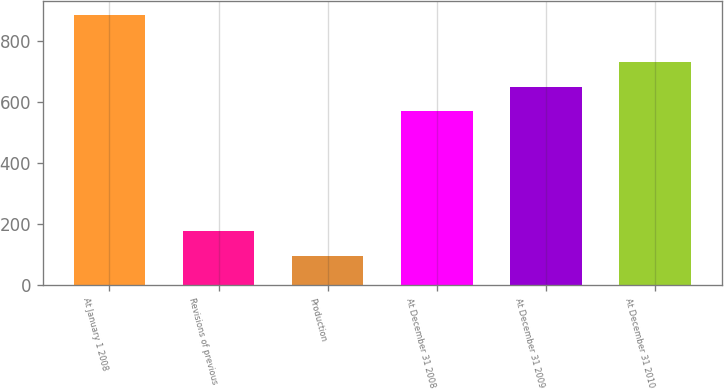<chart> <loc_0><loc_0><loc_500><loc_500><bar_chart><fcel>At January 1 2008<fcel>Revisions of previous<fcel>Production<fcel>At December 31 2008<fcel>At December 31 2009<fcel>At December 31 2010<nl><fcel>885<fcel>175.8<fcel>97<fcel>571<fcel>649.8<fcel>728.6<nl></chart> 